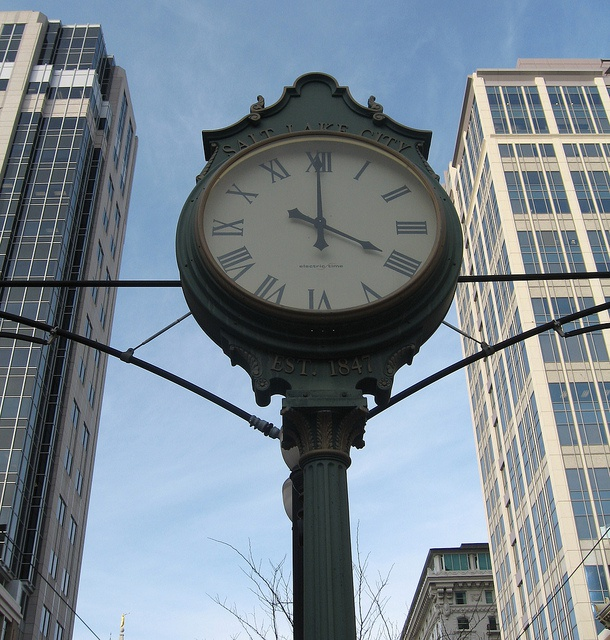Describe the objects in this image and their specific colors. I can see a clock in darkgray, gray, black, and purple tones in this image. 